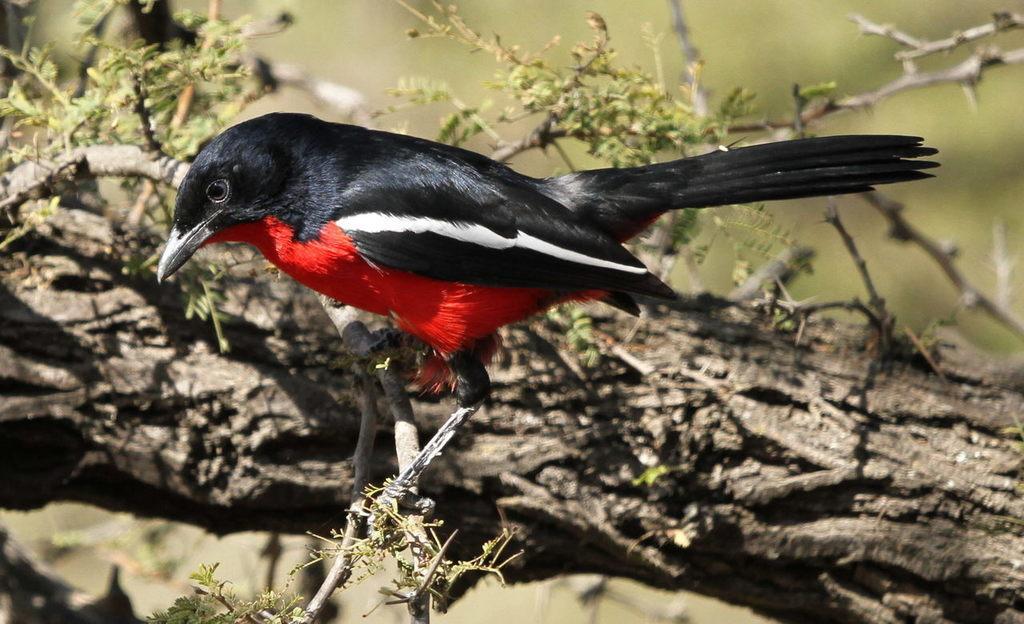Describe this image in one or two sentences. In the image there is bird standing on stem of a tree, the bird is in black and red color with white stripe on it. 